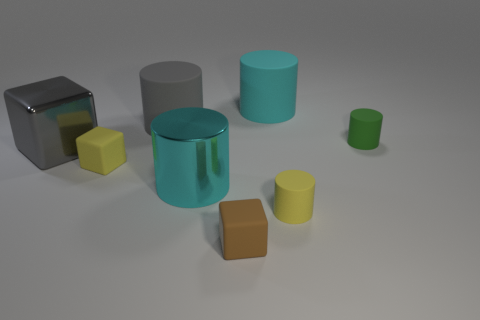Subtract 2 cylinders. How many cylinders are left? 3 Subtract all green cylinders. How many cylinders are left? 4 Subtract all yellow cylinders. How many cylinders are left? 4 Subtract all brown cylinders. Subtract all blue spheres. How many cylinders are left? 5 Add 1 cyan rubber things. How many objects exist? 9 Subtract all cylinders. How many objects are left? 3 Subtract 1 yellow cubes. How many objects are left? 7 Subtract all big gray cylinders. Subtract all rubber things. How many objects are left? 1 Add 3 rubber cubes. How many rubber cubes are left? 5 Add 7 tiny green rubber objects. How many tiny green rubber objects exist? 8 